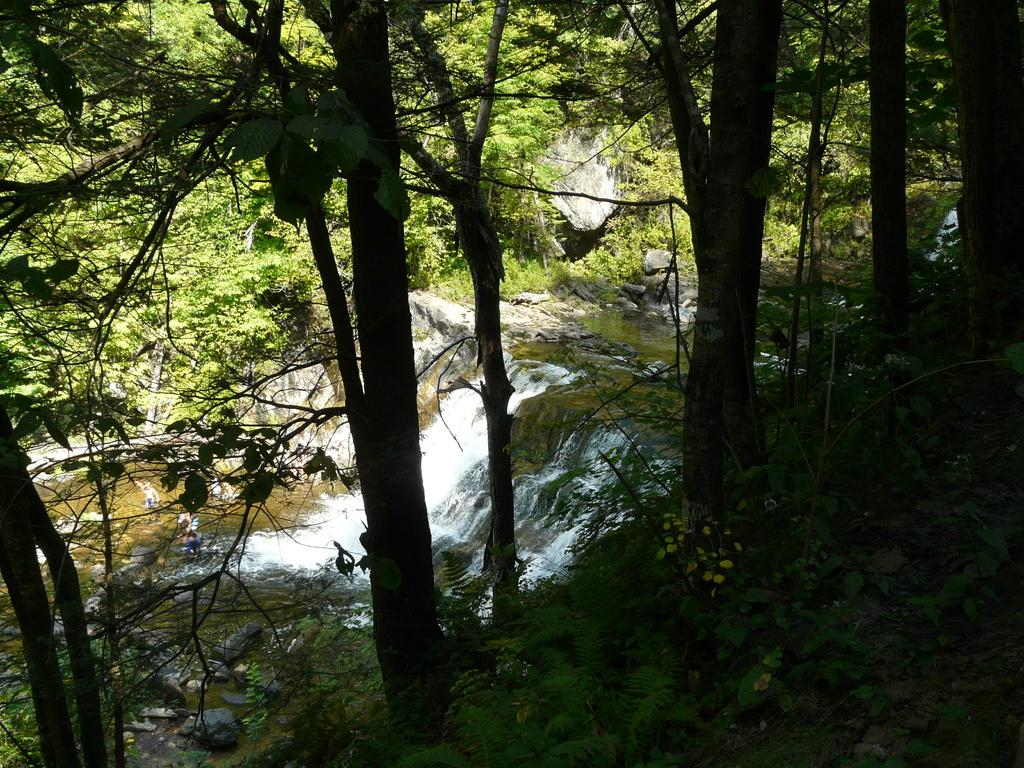What type of vegetation is at the bottom of the image? There are small plants with leaves at the bottom of the image. What other types of vegetation can be seen in the image? There are trees in the image. What natural feature is visible in the background? There is a waterfall in the background. What else can be seen in the background of the image? There are rocks and trees visible in the background. Can you describe the rainstorm happening in the image? There is no rainstorm present in the image; it features a waterfall and vegetation. What type of plane is flying in the image? There is no plane present in the image. 